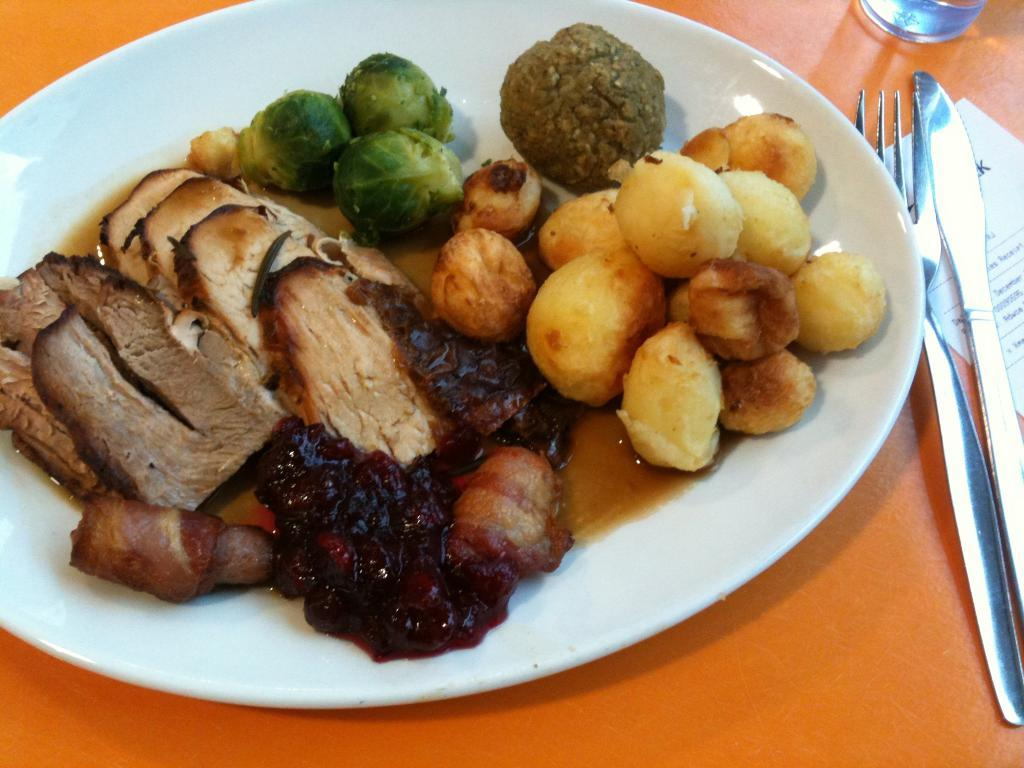What utensils can be seen in the image? There is a fork and a knife in the image. What else is present on the table besides utensils? There is a paper, a glass, and a plate with food items in the image. What might be used for drinking in the image? The glass in the image might be used for drinking. What is the purpose of the plate in the image? The plate in the image is used to hold food items. What type of button can be seen hanging from the icicle in the image? There is no icicle or button present in the image. Is there any reference to a wrist in the image? No, there is no mention of a wrist or any related objects in the image. 